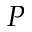Convert formula to latex. <formula><loc_0><loc_0><loc_500><loc_500>P</formula> 